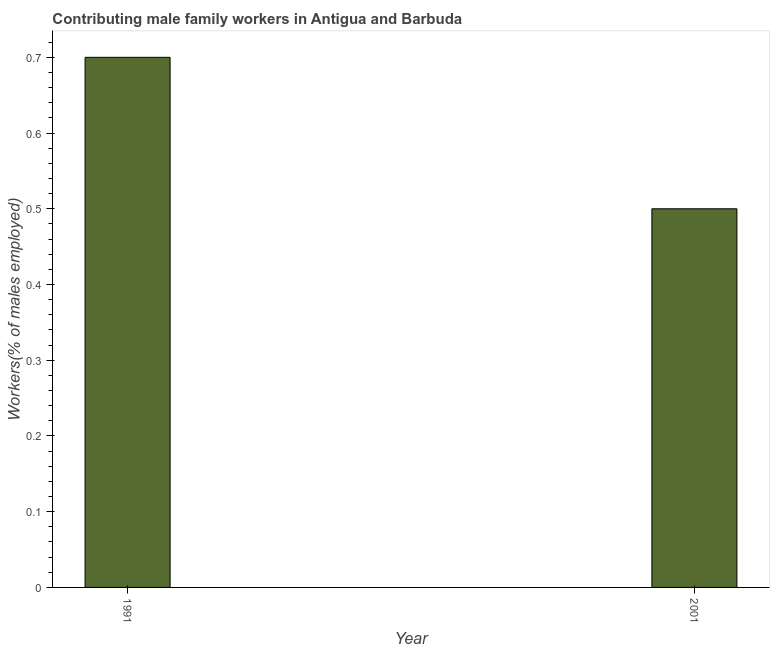What is the title of the graph?
Provide a short and direct response. Contributing male family workers in Antigua and Barbuda. What is the label or title of the X-axis?
Provide a short and direct response. Year. What is the label or title of the Y-axis?
Ensure brevity in your answer.  Workers(% of males employed). Across all years, what is the maximum contributing male family workers?
Provide a succinct answer. 0.7. Across all years, what is the minimum contributing male family workers?
Keep it short and to the point. 0.5. In which year was the contributing male family workers minimum?
Keep it short and to the point. 2001. What is the sum of the contributing male family workers?
Your response must be concise. 1.2. What is the difference between the contributing male family workers in 1991 and 2001?
Offer a terse response. 0.2. What is the average contributing male family workers per year?
Your response must be concise. 0.6. What is the median contributing male family workers?
Give a very brief answer. 0.6. In how many years, is the contributing male family workers greater than 0.22 %?
Offer a very short reply. 2. Do a majority of the years between 1991 and 2001 (inclusive) have contributing male family workers greater than 0.56 %?
Keep it short and to the point. No. What is the ratio of the contributing male family workers in 1991 to that in 2001?
Make the answer very short. 1.4. Are the values on the major ticks of Y-axis written in scientific E-notation?
Keep it short and to the point. No. What is the Workers(% of males employed) of 1991?
Keep it short and to the point. 0.7. What is the ratio of the Workers(% of males employed) in 1991 to that in 2001?
Give a very brief answer. 1.4. 